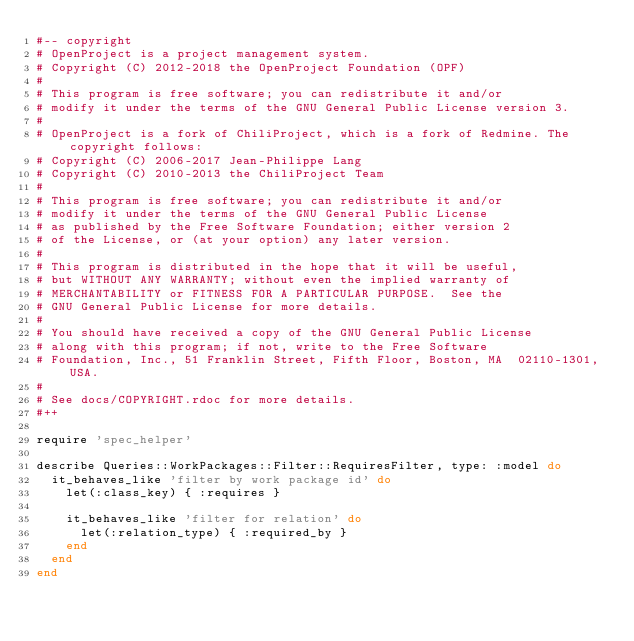Convert code to text. <code><loc_0><loc_0><loc_500><loc_500><_Ruby_>#-- copyright
# OpenProject is a project management system.
# Copyright (C) 2012-2018 the OpenProject Foundation (OPF)
#
# This program is free software; you can redistribute it and/or
# modify it under the terms of the GNU General Public License version 3.
#
# OpenProject is a fork of ChiliProject, which is a fork of Redmine. The copyright follows:
# Copyright (C) 2006-2017 Jean-Philippe Lang
# Copyright (C) 2010-2013 the ChiliProject Team
#
# This program is free software; you can redistribute it and/or
# modify it under the terms of the GNU General Public License
# as published by the Free Software Foundation; either version 2
# of the License, or (at your option) any later version.
#
# This program is distributed in the hope that it will be useful,
# but WITHOUT ANY WARRANTY; without even the implied warranty of
# MERCHANTABILITY or FITNESS FOR A PARTICULAR PURPOSE.  See the
# GNU General Public License for more details.
#
# You should have received a copy of the GNU General Public License
# along with this program; if not, write to the Free Software
# Foundation, Inc., 51 Franklin Street, Fifth Floor, Boston, MA  02110-1301, USA.
#
# See docs/COPYRIGHT.rdoc for more details.
#++

require 'spec_helper'

describe Queries::WorkPackages::Filter::RequiresFilter, type: :model do
  it_behaves_like 'filter by work package id' do
    let(:class_key) { :requires }

    it_behaves_like 'filter for relation' do
      let(:relation_type) { :required_by }
    end
  end
end
</code> 